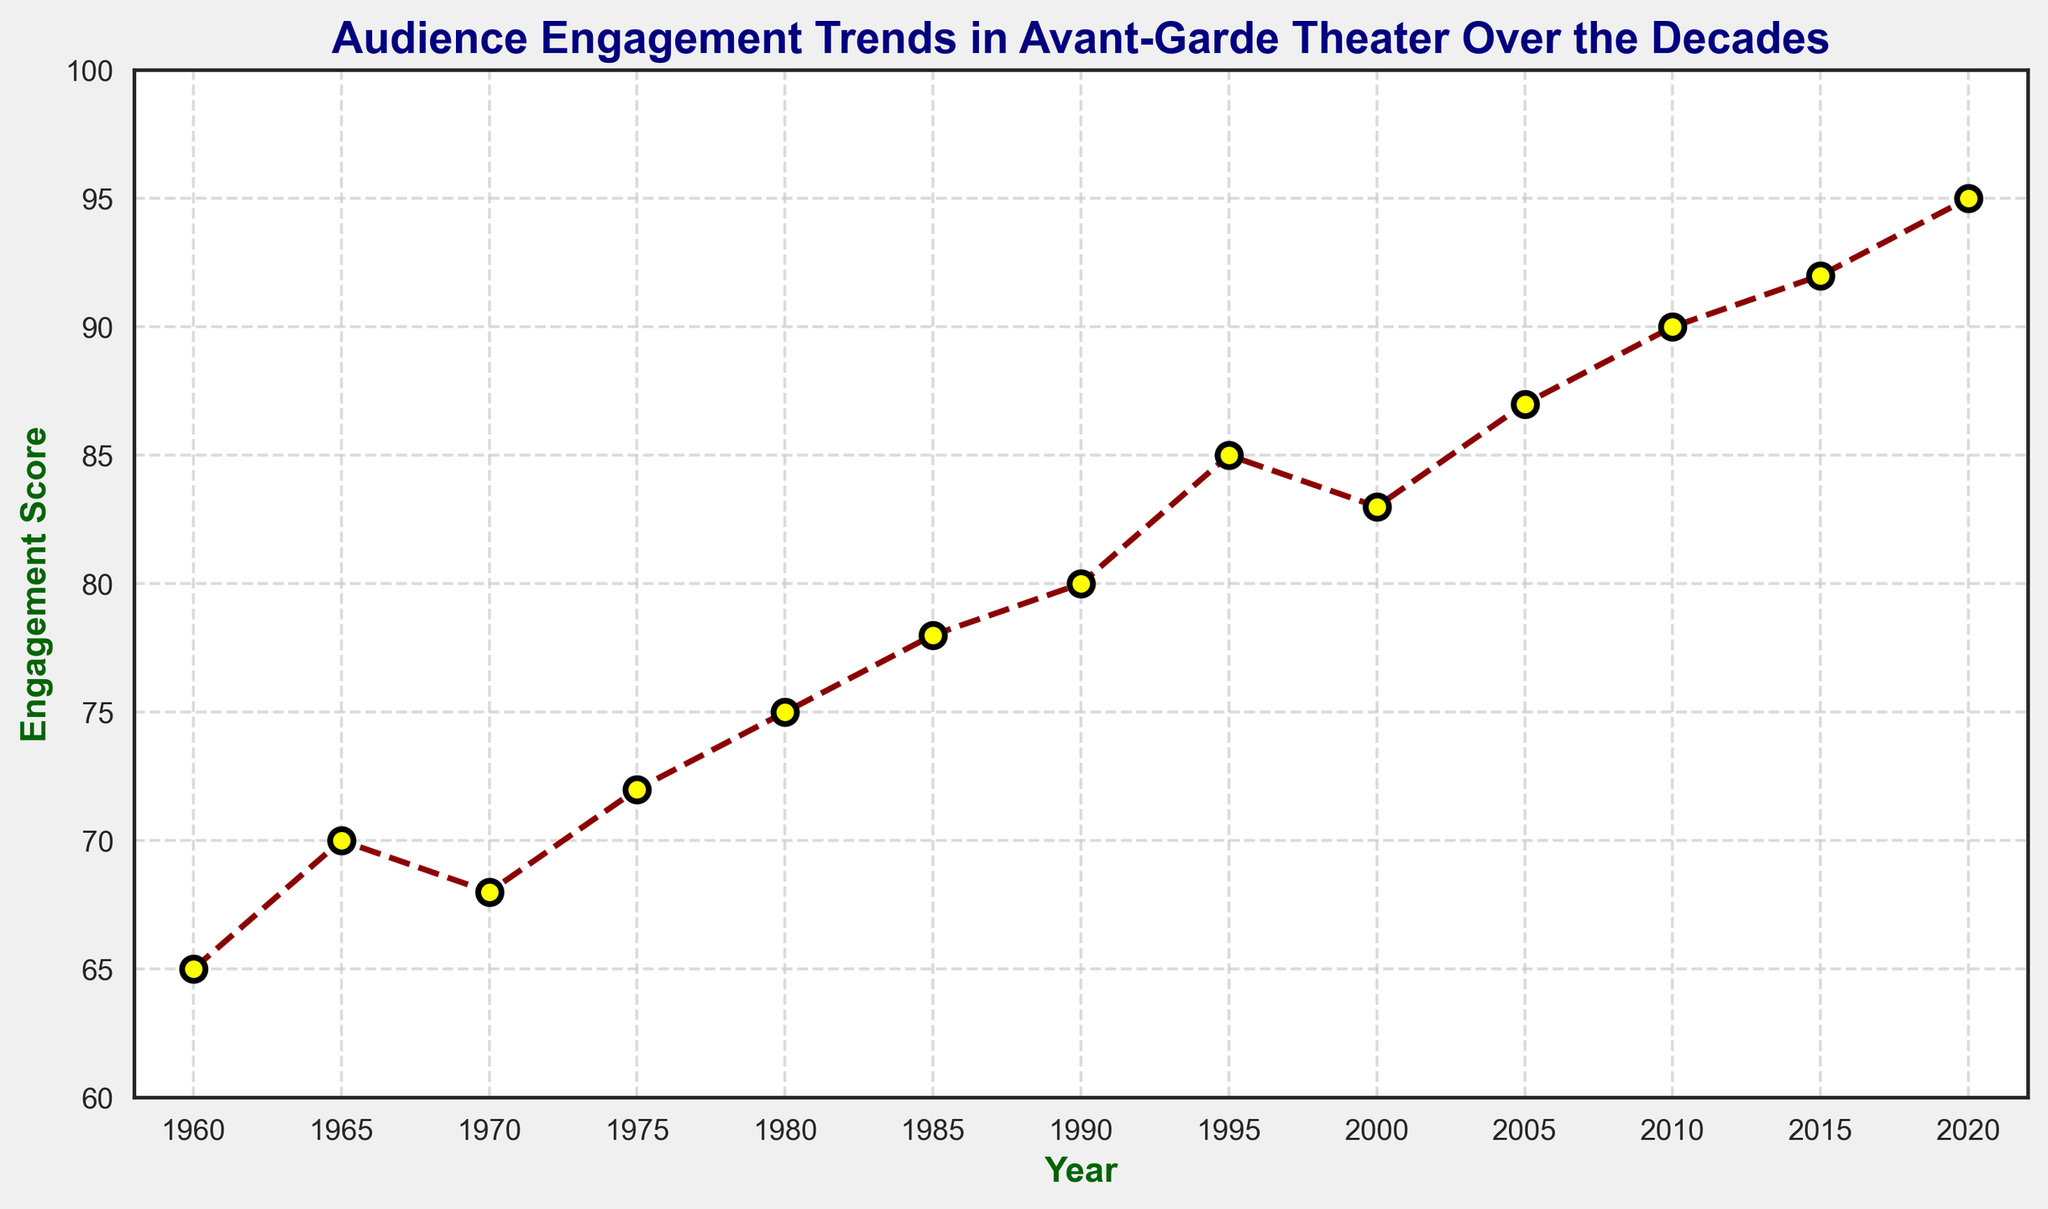What's the highest engagement score recorded in the data? Looking at the chart, the highest point on the line represents the peak engagement score. From the data points on the line, the highest engagement score is recorded in 2020.
Answer: 95 Which year had the lowest engagement score? Observing the line chart, the lowest point represents the minimum engagement score. From the data points, the year with the lowest engagement score is 1960.
Answer: 1960 Between which consecutive years did the engagement score increase the most? Calculate the differences between consecutive engagement scores and find the maximum difference. The largest increase is between 1995 (85) and 2000 (83), differing by 8 points.
Answer: 1995-2000 What is the average engagement score from 1960 to 2020? Sum all engagement scores and divide by the number of data points. Sum = 65+70+68+72+75+78+80+85+83+87+90+92+95 = 1030. Number of years = 13. Average = 1030/13 ≈ 79.23
Answer: 79.23 Which decade saw the highest overall increase in engagement scores? Calculate the engagement score change for each decade and compare. 1960s: +5, 1970s: +4, 1980s: +6, 1990s: +10, 2000s: +4, 2010s: +5. The 1990s saw the highest increase of 10 points.
Answer: 1990s How many years show a decrease in engagement scores compared to the previous year? Identify years where the engagement score is lower than the previous year. The years identified are 1970 and 2000.
Answer: 2 What visual attributes make the highest and lowest engagement scores distinguishable? The highest value in 2020 is marked with a yellow-filled marker at the top. The lowest value in 1960 is marked similarly at the bottom. Color and position on the y-axis are used to distinguish them.
Answer: Yellow marker, position on y-axis By how much did the engagement score increase from 1960 to 2020? Subtract the engagement score in 1960 from the engagement score in 2020. 95 - 65 = 30. The score increased by 30 points over this period.
Answer: 30 points Is there a decade where the engagement score remained the same or decreased overall? Check each decade's start and end years. Only the 2000s show a decreasing trend, dropping from 87 in 2005 to 83 in 2000.
Answer: 2000s How does the overall trend in audience engagement over the decades appear? The line chart shows a general upward trend from 1960 to 2020, with occasional minor fluctuations. The engagement score gradually increases over time.
Answer: Upward trend 